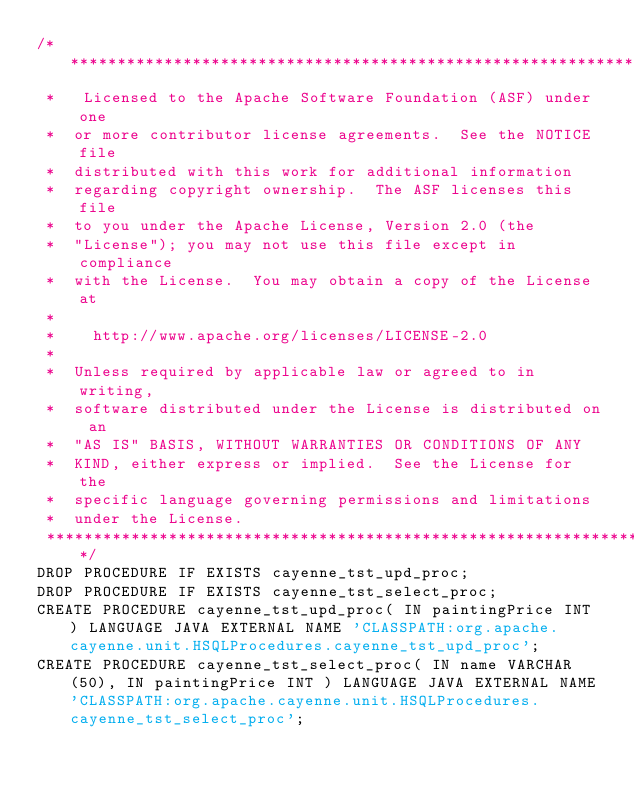Convert code to text. <code><loc_0><loc_0><loc_500><loc_500><_SQL_>/*****************************************************************
 *   Licensed to the Apache Software Foundation (ASF) under one
 *  or more contributor license agreements.  See the NOTICE file
 *  distributed with this work for additional information
 *  regarding copyright ownership.  The ASF licenses this file
 *  to you under the Apache License, Version 2.0 (the
 *  "License"); you may not use this file except in compliance
 *  with the License.  You may obtain a copy of the License at
 *
 *    http://www.apache.org/licenses/LICENSE-2.0
 *
 *  Unless required by applicable law or agreed to in writing,
 *  software distributed under the License is distributed on an
 *  "AS IS" BASIS, WITHOUT WARRANTIES OR CONDITIONS OF ANY
 *  KIND, either express or implied.  See the License for the
 *  specific language governing permissions and limitations
 *  under the License.
 ****************************************************************/
DROP PROCEDURE IF EXISTS cayenne_tst_upd_proc;
DROP PROCEDURE IF EXISTS cayenne_tst_select_proc;
CREATE PROCEDURE cayenne_tst_upd_proc( IN paintingPrice INT ) LANGUAGE JAVA EXTERNAL NAME 'CLASSPATH:org.apache.cayenne.unit.HSQLProcedures.cayenne_tst_upd_proc';
CREATE PROCEDURE cayenne_tst_select_proc( IN name VARCHAR(50), IN paintingPrice INT ) LANGUAGE JAVA EXTERNAL NAME 'CLASSPATH:org.apache.cayenne.unit.HSQLProcedures.cayenne_tst_select_proc';</code> 